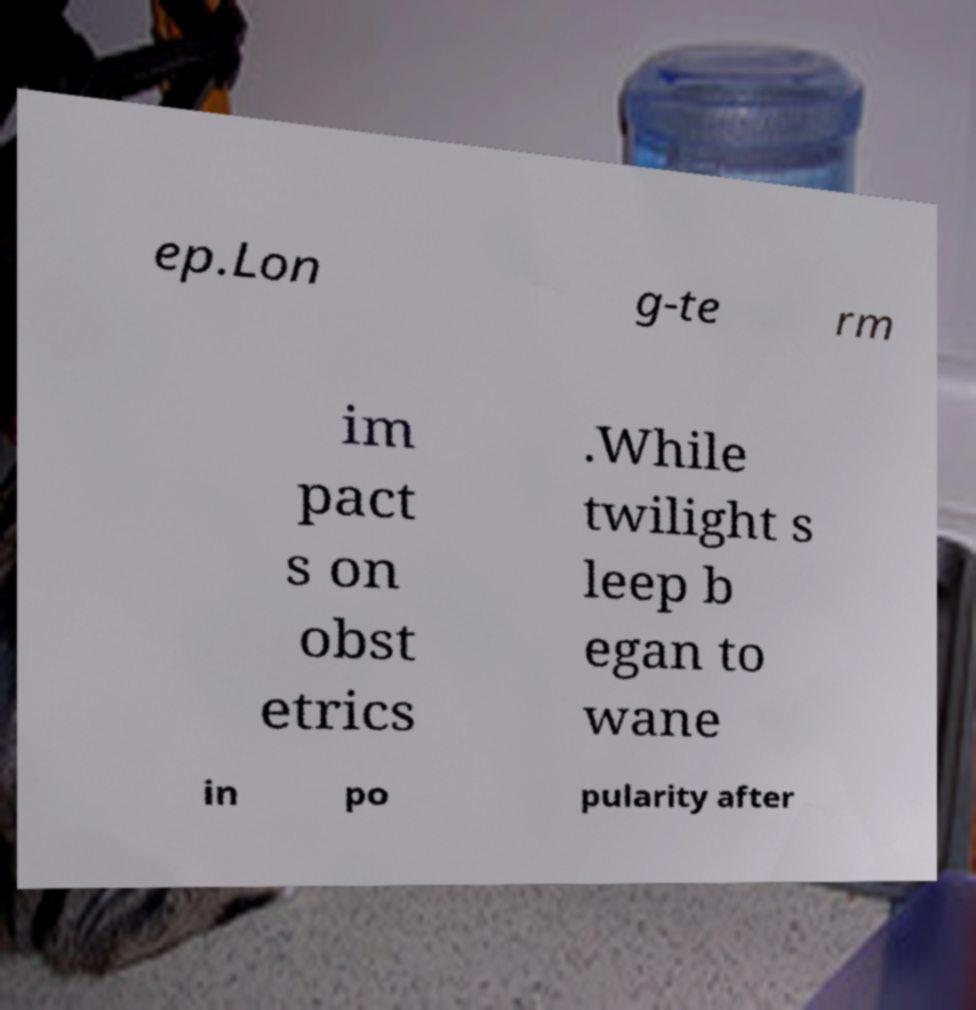There's text embedded in this image that I need extracted. Can you transcribe it verbatim? ep.Lon g-te rm im pact s on obst etrics .While twilight s leep b egan to wane in po pularity after 